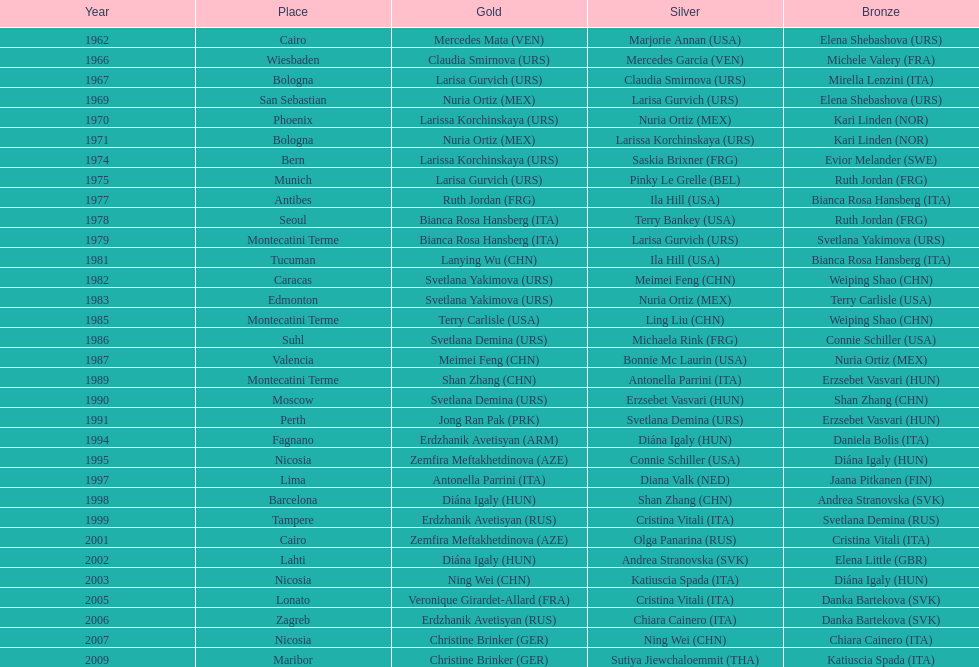Which country has won more gold medals: china or mexico? China. 